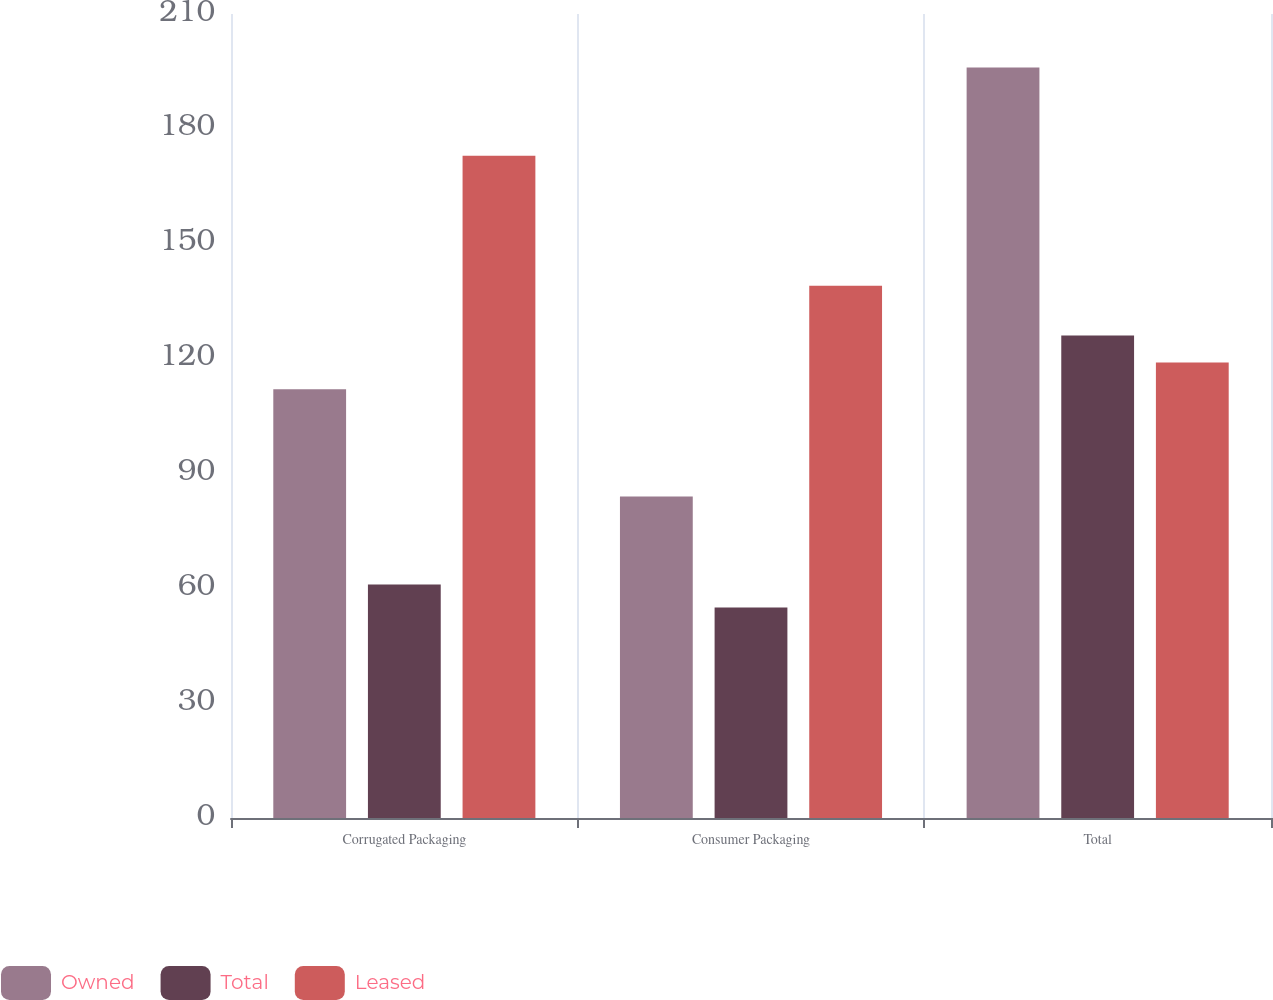Convert chart. <chart><loc_0><loc_0><loc_500><loc_500><stacked_bar_chart><ecel><fcel>Corrugated Packaging<fcel>Consumer Packaging<fcel>Total<nl><fcel>Owned<fcel>112<fcel>84<fcel>196<nl><fcel>Total<fcel>61<fcel>55<fcel>126<nl><fcel>Leased<fcel>173<fcel>139<fcel>119<nl></chart> 